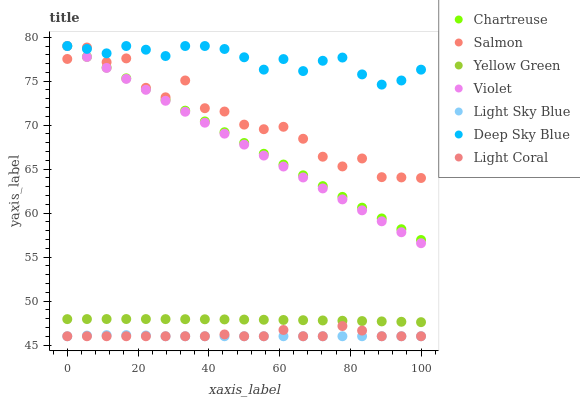Does Light Sky Blue have the minimum area under the curve?
Answer yes or no. Yes. Does Deep Sky Blue have the maximum area under the curve?
Answer yes or no. Yes. Does Salmon have the minimum area under the curve?
Answer yes or no. No. Does Salmon have the maximum area under the curve?
Answer yes or no. No. Is Violet the smoothest?
Answer yes or no. Yes. Is Salmon the roughest?
Answer yes or no. Yes. Is Light Coral the smoothest?
Answer yes or no. No. Is Light Coral the roughest?
Answer yes or no. No. Does Light Coral have the lowest value?
Answer yes or no. Yes. Does Salmon have the lowest value?
Answer yes or no. No. Does Violet have the highest value?
Answer yes or no. Yes. Does Salmon have the highest value?
Answer yes or no. No. Is Yellow Green less than Salmon?
Answer yes or no. Yes. Is Salmon greater than Light Sky Blue?
Answer yes or no. Yes. Does Salmon intersect Deep Sky Blue?
Answer yes or no. Yes. Is Salmon less than Deep Sky Blue?
Answer yes or no. No. Is Salmon greater than Deep Sky Blue?
Answer yes or no. No. Does Yellow Green intersect Salmon?
Answer yes or no. No. 